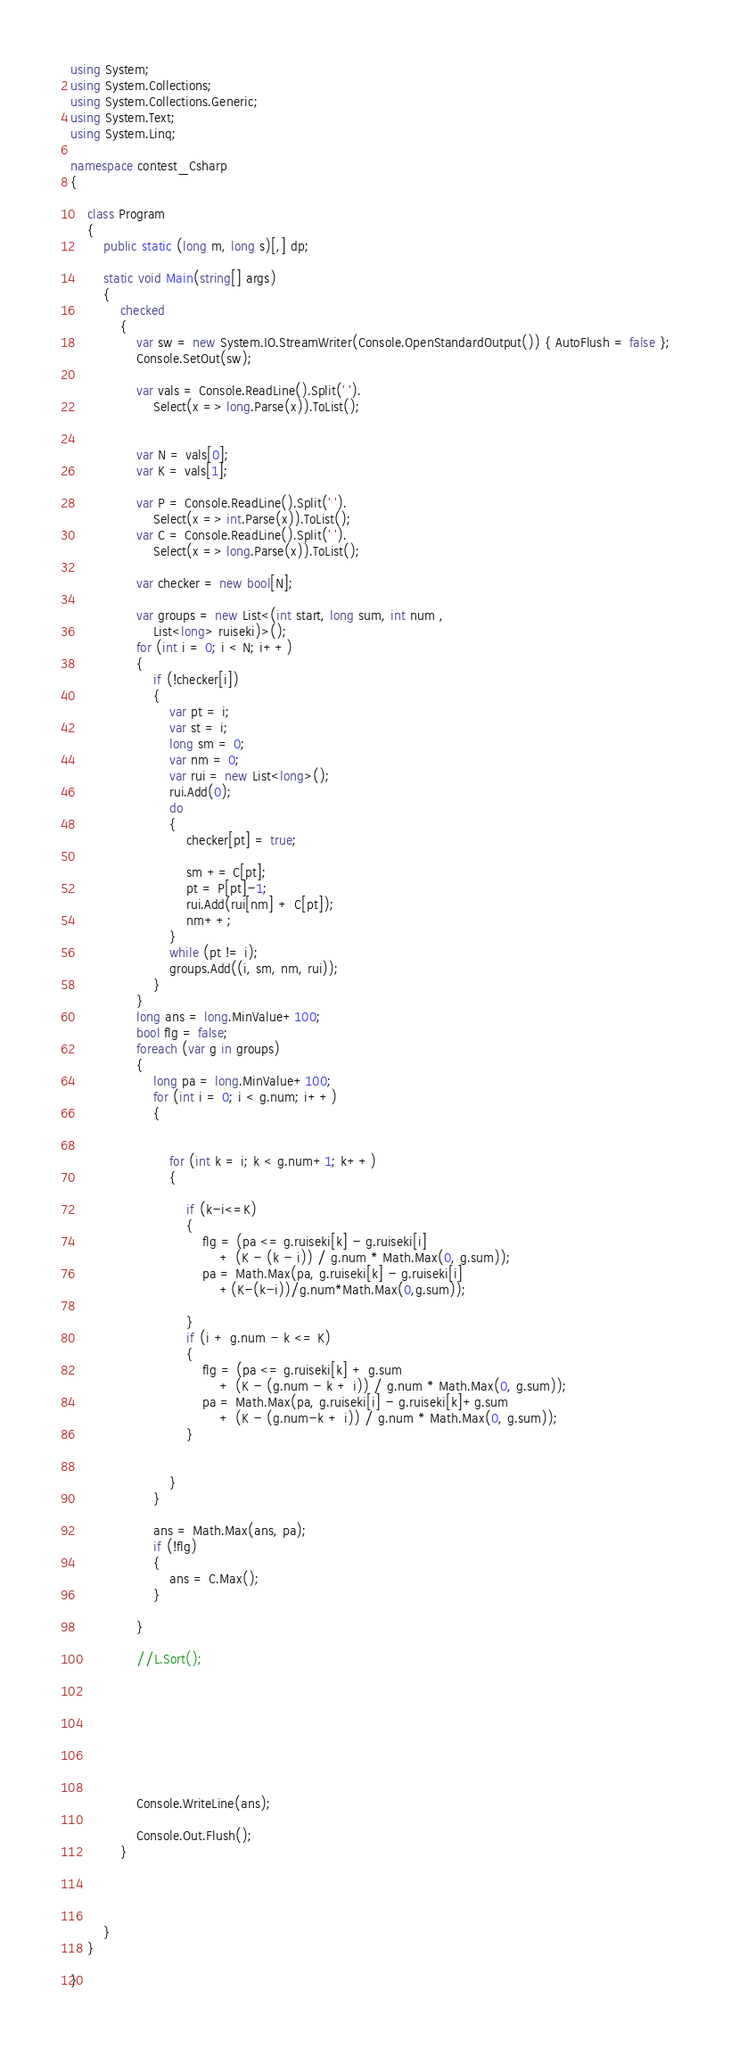Convert code to text. <code><loc_0><loc_0><loc_500><loc_500><_C#_>using System;
using System.Collections;
using System.Collections.Generic;
using System.Text;
using System.Linq;

namespace contest_Csharp
{

    class Program
    {
        public static (long m, long s)[,] dp;

        static void Main(string[] args)
        {
            checked
            {
                var sw = new System.IO.StreamWriter(Console.OpenStandardOutput()) { AutoFlush = false };
                Console.SetOut(sw);

                var vals = Console.ReadLine().Split(' ').
                    Select(x => long.Parse(x)).ToList();


                var N = vals[0];
                var K = vals[1];

                var P = Console.ReadLine().Split(' ').
                    Select(x => int.Parse(x)).ToList();
                var C = Console.ReadLine().Split(' ').
                    Select(x => long.Parse(x)).ToList();

                var checker = new bool[N];

                var groups = new List<(int start, long sum, int num ,
                    List<long> ruiseki)>();
                for (int i = 0; i < N; i++)
                {
                    if (!checker[i])
                    {
                        var pt = i;
                        var st = i;
                        long sm = 0;
                        var nm = 0;
                        var rui = new List<long>();
                        rui.Add(0);
                        do 
                        {
                            checker[pt] = true;

                            sm += C[pt];
                            pt = P[pt]-1;
                            rui.Add(rui[nm] + C[pt]);
                            nm++;
                        }
                        while (pt != i);
                        groups.Add((i, sm, nm, rui));
                    }
                }
                long ans = long.MinValue+100;
                bool flg = false;
                foreach (var g in groups)
                {
                    long pa = long.MinValue+100;
                    for (int i = 0; i < g.num; i++)
                    {
                        

                        for (int k = i; k < g.num+1; k++)
                        {
                            
                            if (k-i<=K)
                            {
                                flg = (pa <= g.ruiseki[k] - g.ruiseki[i]
                                    + (K - (k - i)) / g.num * Math.Max(0, g.sum));
                                pa = Math.Max(pa, g.ruiseki[k] - g.ruiseki[i]
                                    +(K-(k-i))/g.num*Math.Max(0,g.sum));

                            }
                            if (i + g.num - k <= K)
                            {
                                flg = (pa <= g.ruiseki[k] + g.sum
                                    + (K - (g.num - k + i)) / g.num * Math.Max(0, g.sum));
                                pa = Math.Max(pa, g.ruiseki[i] - g.ruiseki[k]+g.sum
                                    + (K - (g.num-k + i)) / g.num * Math.Max(0, g.sum));
                            }
                            

                        }
                    }
                    
                    ans = Math.Max(ans, pa);
                    if (!flg)
                    {
                        ans = C.Max();
                    }

                }

                //L.Sort();

                






                Console.WriteLine(ans);

                Console.Out.Flush();
            }




        }
    }

}


</code> 